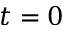<formula> <loc_0><loc_0><loc_500><loc_500>t = 0</formula> 